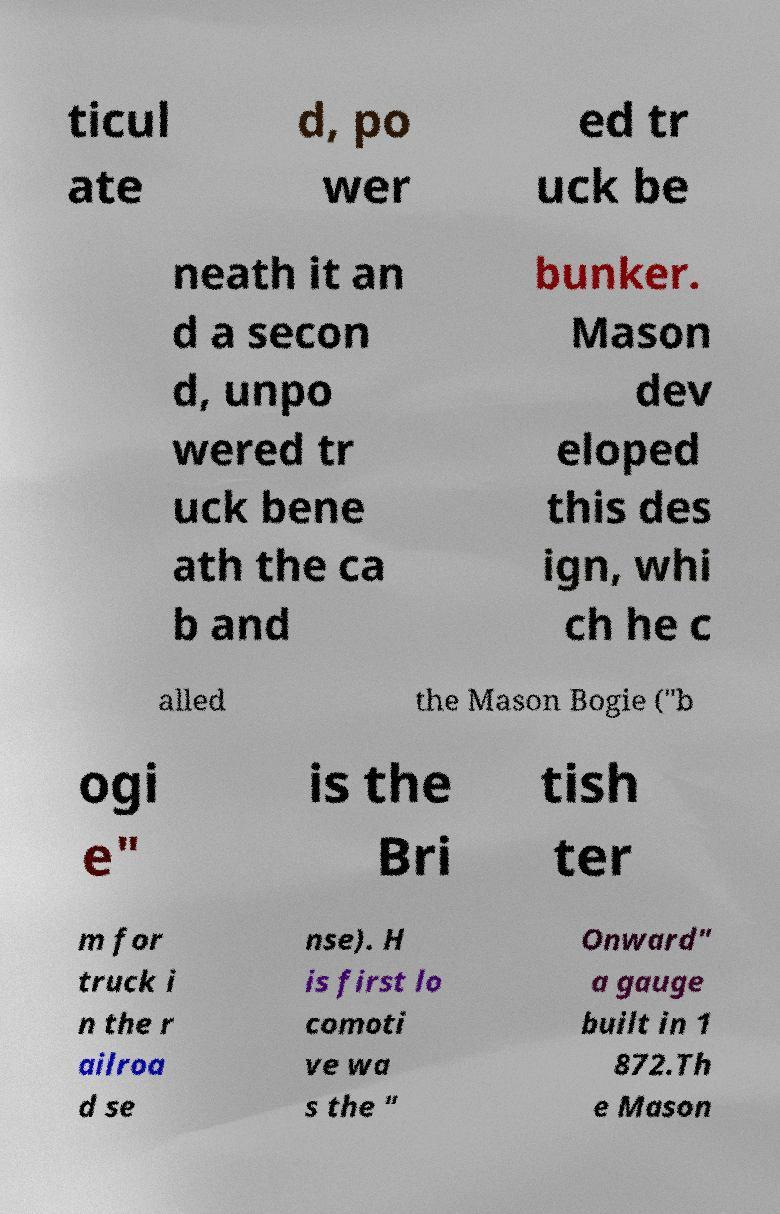For documentation purposes, I need the text within this image transcribed. Could you provide that? ticul ate d, po wer ed tr uck be neath it an d a secon d, unpo wered tr uck bene ath the ca b and bunker. Mason dev eloped this des ign, whi ch he c alled the Mason Bogie ("b ogi e" is the Bri tish ter m for truck i n the r ailroa d se nse). H is first lo comoti ve wa s the " Onward" a gauge built in 1 872.Th e Mason 